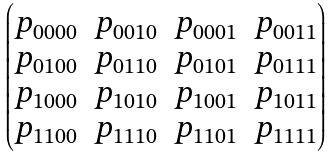<formula> <loc_0><loc_0><loc_500><loc_500>\begin{pmatrix} p _ { 0 0 0 0 } & p _ { 0 0 1 0 } & p _ { 0 0 0 1 } & p _ { 0 0 1 1 } \\ p _ { 0 1 0 0 } & p _ { 0 1 1 0 } & p _ { 0 1 0 1 } & p _ { 0 1 1 1 } \\ p _ { 1 0 0 0 } & p _ { 1 0 1 0 } & p _ { 1 0 0 1 } & p _ { 1 0 1 1 } \\ p _ { 1 1 0 0 } & p _ { 1 1 1 0 } & p _ { 1 1 0 1 } & p _ { 1 1 1 1 } \end{pmatrix}</formula> 